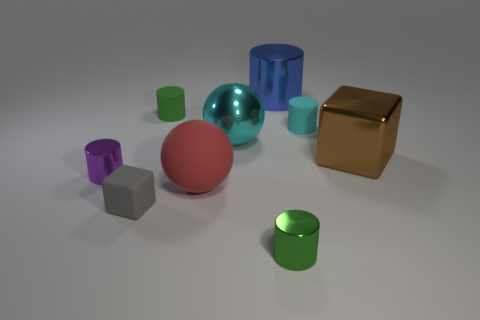Can you comment on the lighting and shadows in the image? The lighting in the image comes from the upper left, casting shadows towards the lower right. This setup provides a soft illumination and enhances the three-dimensional feel of the objects through the nuanced shadows and highlights. 